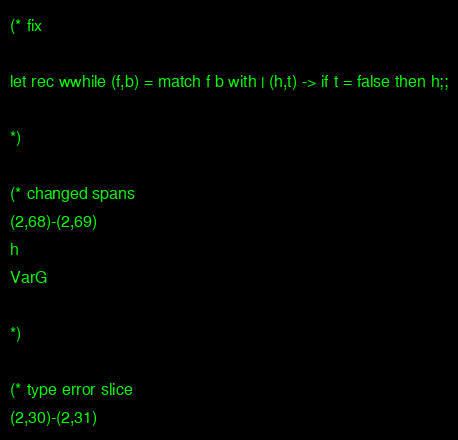Convert code to text. <code><loc_0><loc_0><loc_500><loc_500><_OCaml_>(* fix

let rec wwhile (f,b) = match f b with | (h,t) -> if t = false then h;;

*)

(* changed spans
(2,68)-(2,69)
h
VarG

*)

(* type error slice
(2,30)-(2,31)</code> 